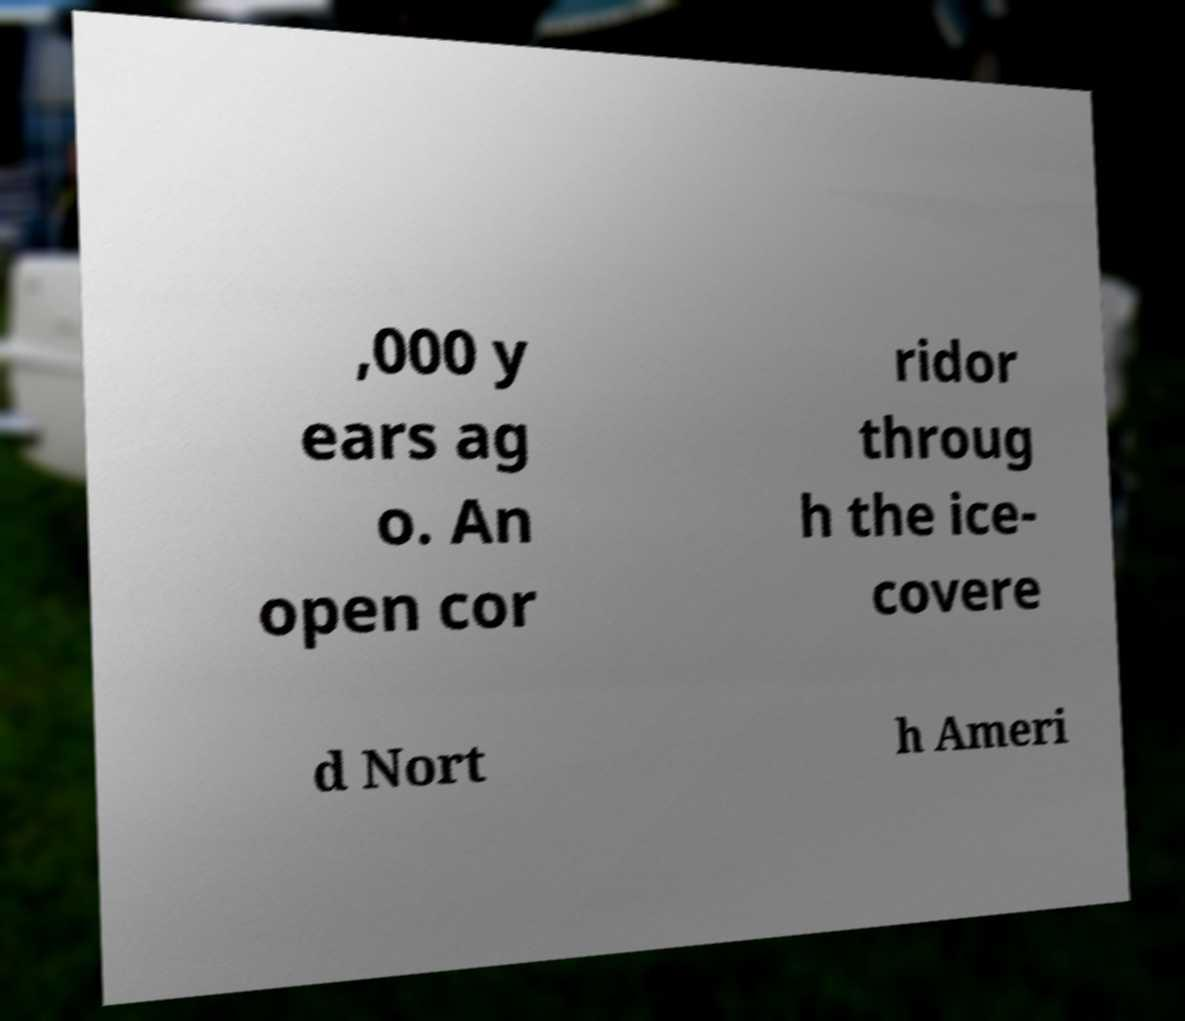Please identify and transcribe the text found in this image. ,000 y ears ag o. An open cor ridor throug h the ice- covere d Nort h Ameri 